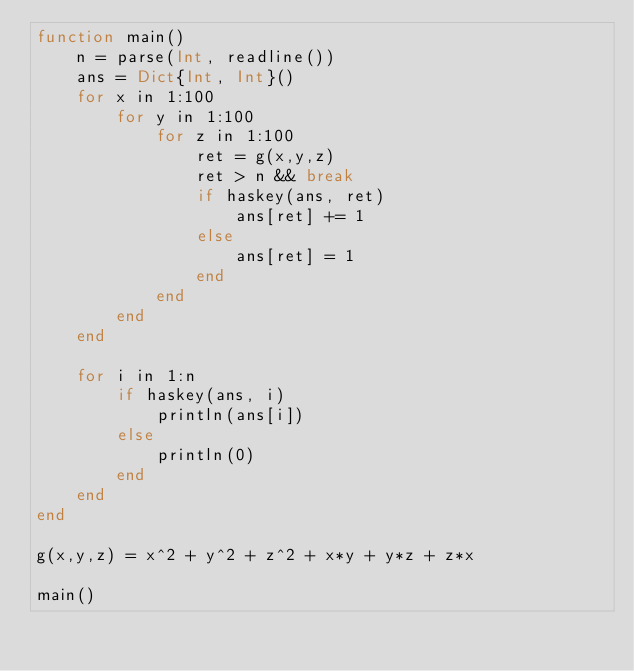Convert code to text. <code><loc_0><loc_0><loc_500><loc_500><_Julia_>function main()
    n = parse(Int, readline())
    ans = Dict{Int, Int}()
    for x in 1:100
        for y in 1:100
            for z in 1:100
                ret = g(x,y,z)
                ret > n && break
                if haskey(ans, ret)
                    ans[ret] += 1
                else
                    ans[ret] = 1
                end
            end
        end
    end

    for i in 1:n
        if haskey(ans, i)
            println(ans[i])
        else
            println(0)
        end
    end
end

g(x,y,z) = x^2 + y^2 + z^2 + x*y + y*z + z*x

main()</code> 